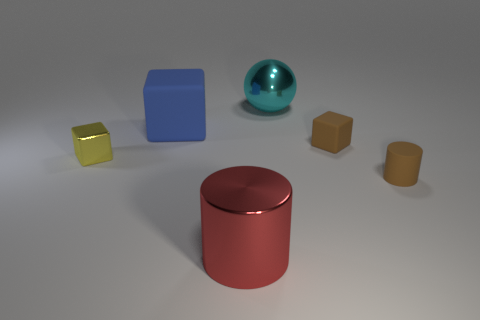What size is the rubber cylinder that is the same color as the tiny rubber cube?
Provide a short and direct response. Small. Is the color of the small matte object that is behind the shiny cube the same as the tiny matte cylinder?
Give a very brief answer. Yes. How many rubber cylinders are to the left of the rubber block to the right of the cylinder to the left of the large cyan shiny sphere?
Provide a succinct answer. 0. What number of large things are behind the tiny yellow block and on the right side of the blue block?
Ensure brevity in your answer.  1. What is the shape of the rubber thing that is the same color as the tiny matte cube?
Provide a short and direct response. Cylinder. Is the material of the cyan sphere the same as the red cylinder?
Your response must be concise. Yes. What shape is the tiny rubber thing right of the brown thing behind the cylinder that is to the right of the cyan metal sphere?
Keep it short and to the point. Cylinder. Is the number of big shiny spheres on the left side of the big cyan thing less than the number of red things on the left side of the small rubber block?
Give a very brief answer. Yes. There is a tiny brown object in front of the tiny block that is on the left side of the red cylinder; what shape is it?
Offer a terse response. Cylinder. Is there anything else of the same color as the big sphere?
Ensure brevity in your answer.  No. 